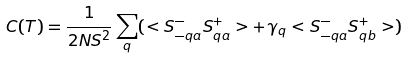<formula> <loc_0><loc_0><loc_500><loc_500>C ( T ) = \frac { 1 } { 2 N S ^ { 2 } } \sum _ { q } ( < S ^ { - } _ { - q a } S ^ { + } _ { q a } > + \gamma _ { q } < S ^ { - } _ { - q a } S ^ { + } _ { q b } > )</formula> 